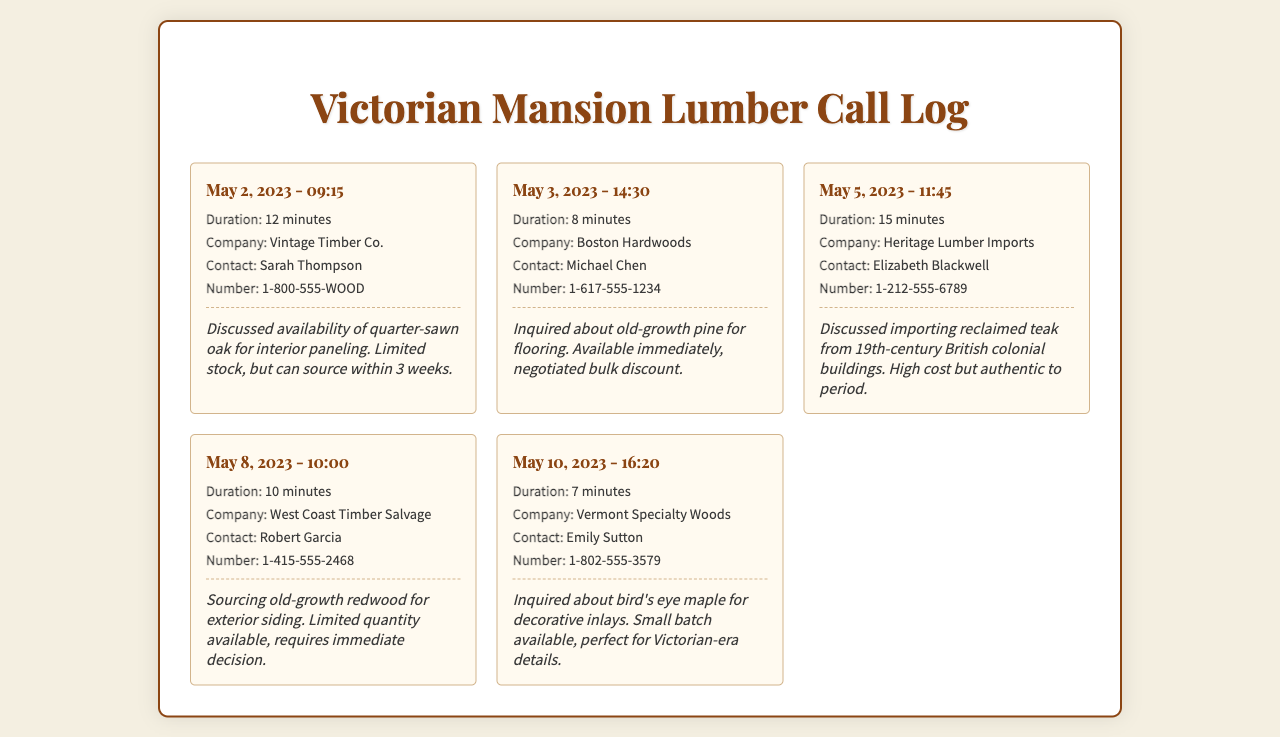What was the call duration for the first entry? The duration of the first call on May 2, 2023, is stated in the call details as 12 minutes.
Answer: 12 minutes Who was the contact person at Boston Hardwoods? The contact listed for Boston Hardwoods is Michael Chen, which can be found in the call details.
Answer: Michael Chen What type of wood was discussed in the call with Heritage Lumber Imports? The call log notes indicate that reclaimed teak was the focus of the discussion with Heritage Lumber Imports.
Answer: reclaimed teak What date was the call made regarding old-growth redwood? The call to West Coast Timber Salvage about old-growth redwood was made on May 8, 2023, according to the call date mentioned.
Answer: May 8, 2023 How many minutes was the shortest call in the log? The shortest call mentioned in the log is 7 minutes long, as detailed in the call entry for Vermont Specialty Woods.
Answer: 7 minutes What company did Sarah Thompson represent? Sarah Thompson is associated with Vintage Timber Co., which appears in the call details.
Answer: Vintage Timber Co What was the availability status of quarter-sawn oak? The notes indicate that quarter-sawn oak had limited stock but could be sourced within 3 weeks during the call with Vintage Timber Co.
Answer: Limited stock Was there a negotiation for a discount in any of the calls? Yes, the call with Boston Hardwoods included a negotiation for a bulk discount, as noted in the call logs.
Answer: Yes 